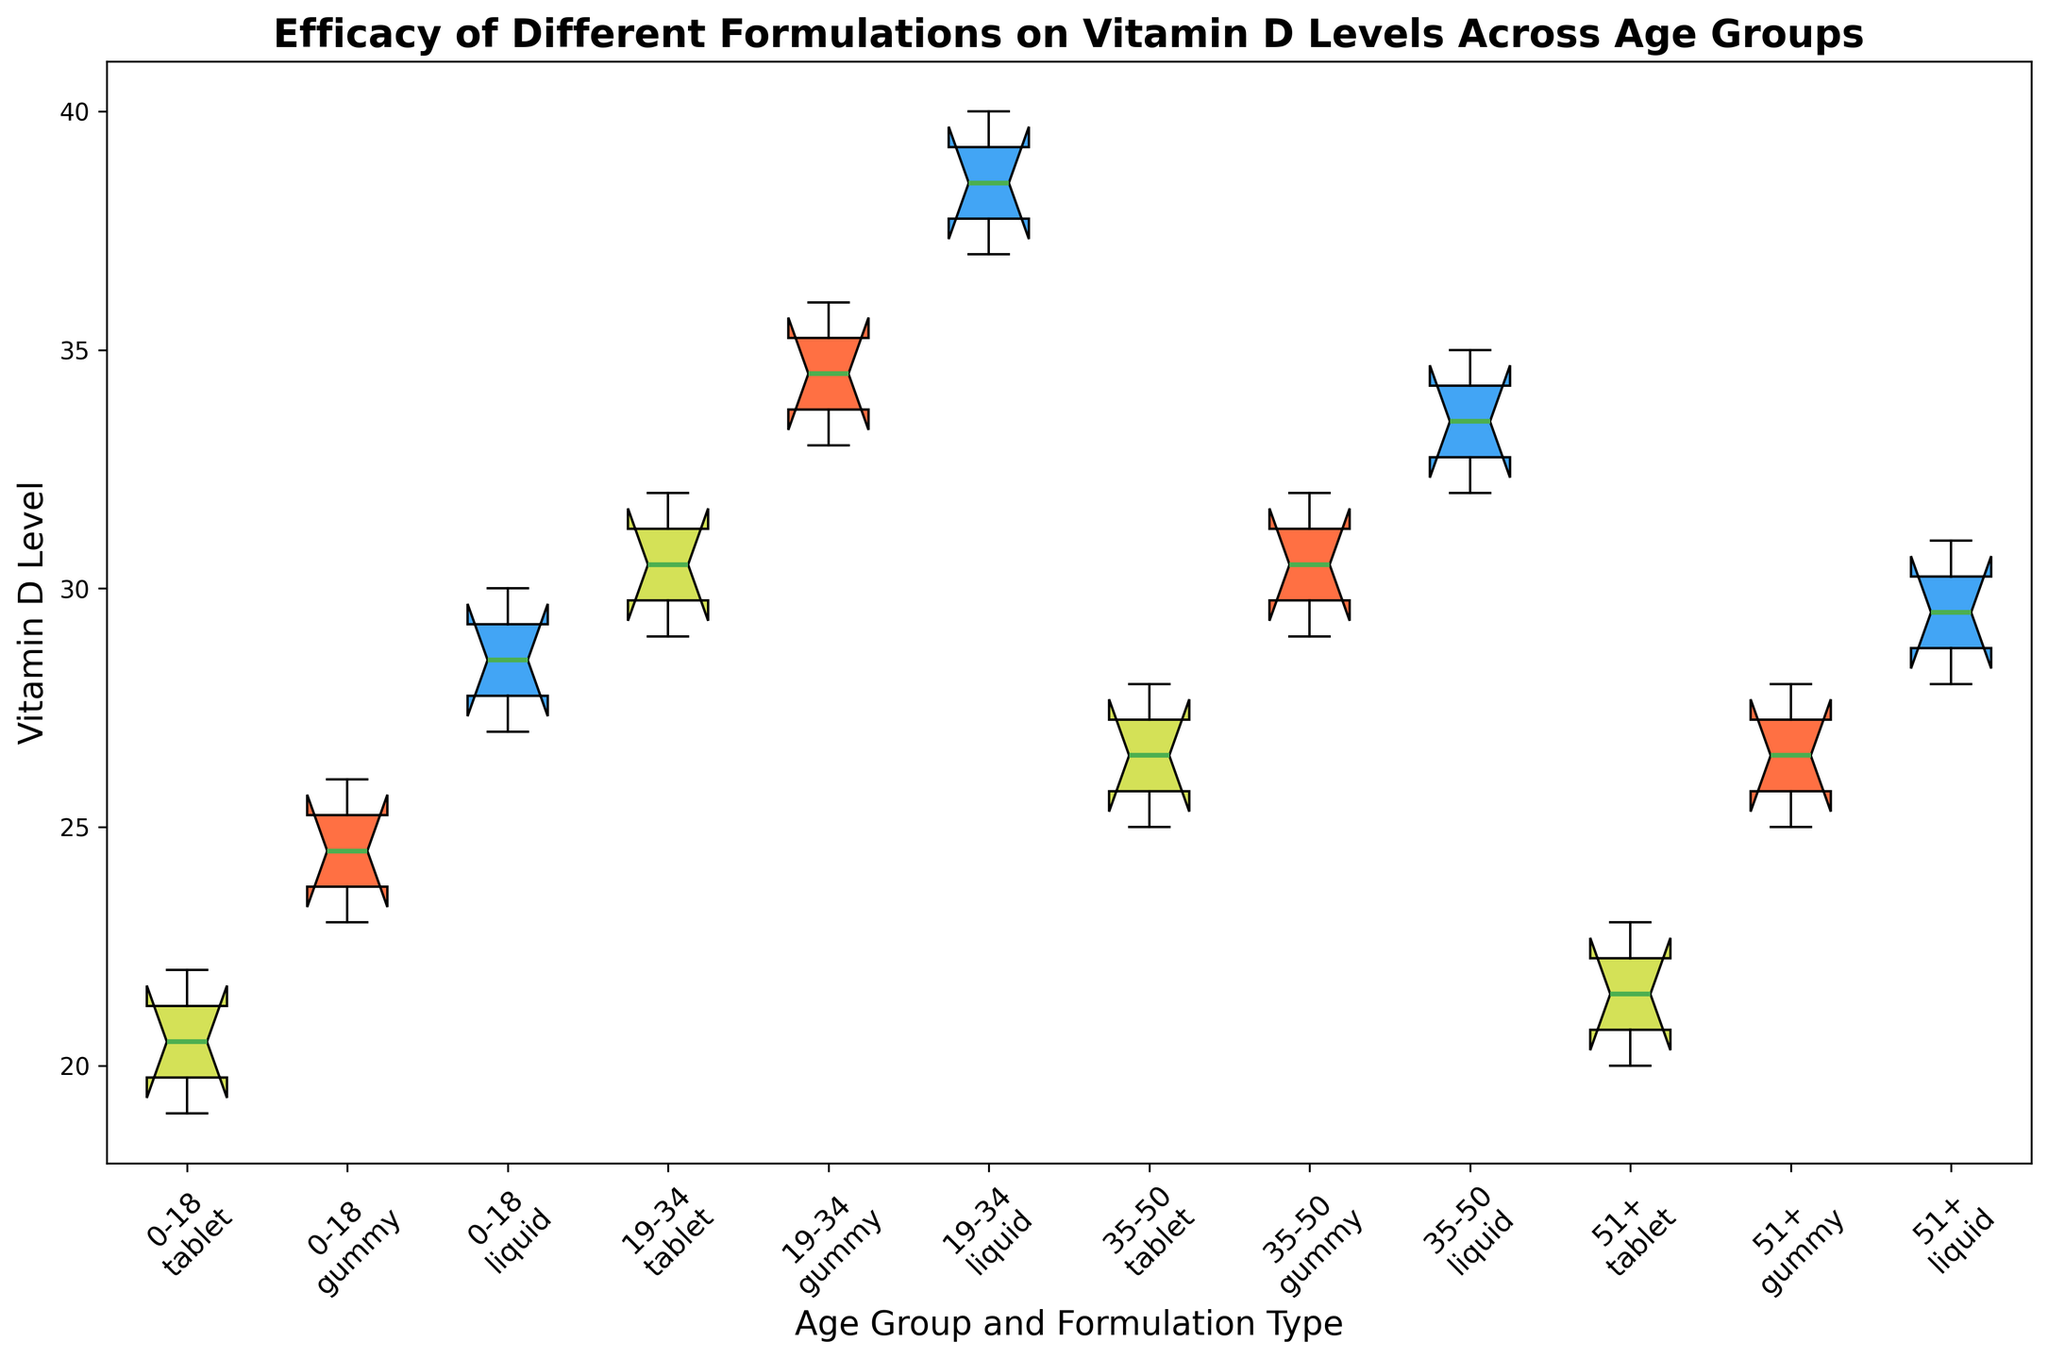What is the median vitamin D level for the 0-18 age group using liquid formulation? Look for the box representing the 0-18 age group using the liquid formulation. The median is indicated by the line within the box. Here it would be around 28.5.
Answer: 28.5 Which formulation type shows the highest median vitamin D level for the 19-34 age group? Compare the medians of the different formulation types for the 19-34 age group. The liquid formulation has the highest median, which is close to 38.5.
Answer: Liquid How do the median vitamin D levels of the tablet formulations compare between the 0-18 and 51+ age groups? Check the medians for the tablet formulations in the 0-18 and 51+ age groups. The medians are nearly the same, around 20.5 for 0-18 and 21.5 for 51+.
Answer: Nearly the same What is the interquartile range (IQR) of the vitamin D level for the 19-34 age group using gummy formulation? Identify the 1st quartile (Q1) and the 3rd quartile (Q3) values within the box for the gummy formulation in the 19-34 age group. The IQR is Q3 - Q1. Q1 is around 33 and Q3 is around 35, so IQR is 35 - 33 = 2.
Answer: 2 Which age group and formulation type combination shows the lowest median vitamin D level? Look for the lowest median across all combinations of age groups and formulation types. The lowest median is seen in the tablet formulation for the 51+ age group, which is around 21.
Answer: 51+, Tablet 